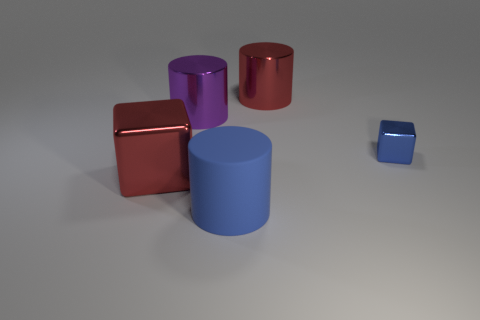Is there a large thing made of the same material as the blue block?
Make the answer very short. Yes. The other thing that is the same color as the small object is what size?
Your answer should be compact. Large. How many cylinders are either big blue things or large metallic objects?
Provide a succinct answer. 3. Are there more large blue matte things right of the small blue metal block than blue metal cubes that are in front of the large blue object?
Your answer should be very brief. No. How many tiny metal cubes are the same color as the big shiny cube?
Ensure brevity in your answer.  0. What size is the blue thing that is made of the same material as the large purple thing?
Provide a succinct answer. Small. How many objects are large metallic things that are on the left side of the big blue rubber object or small blue blocks?
Your response must be concise. 3. There is a thing on the right side of the big red metallic cylinder; does it have the same color as the rubber object?
Offer a very short reply. Yes. The other purple object that is the same shape as the rubber object is what size?
Provide a short and direct response. Large. There is a object that is in front of the red thing that is in front of the blue thing that is on the right side of the large blue cylinder; what is its color?
Keep it short and to the point. Blue. 